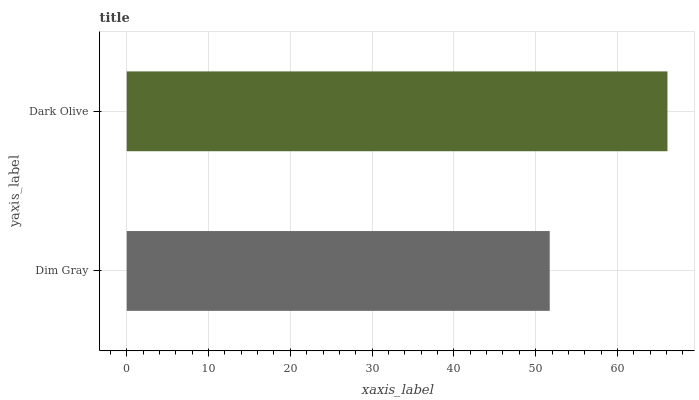Is Dim Gray the minimum?
Answer yes or no. Yes. Is Dark Olive the maximum?
Answer yes or no. Yes. Is Dark Olive the minimum?
Answer yes or no. No. Is Dark Olive greater than Dim Gray?
Answer yes or no. Yes. Is Dim Gray less than Dark Olive?
Answer yes or no. Yes. Is Dim Gray greater than Dark Olive?
Answer yes or no. No. Is Dark Olive less than Dim Gray?
Answer yes or no. No. Is Dark Olive the high median?
Answer yes or no. Yes. Is Dim Gray the low median?
Answer yes or no. Yes. Is Dim Gray the high median?
Answer yes or no. No. Is Dark Olive the low median?
Answer yes or no. No. 